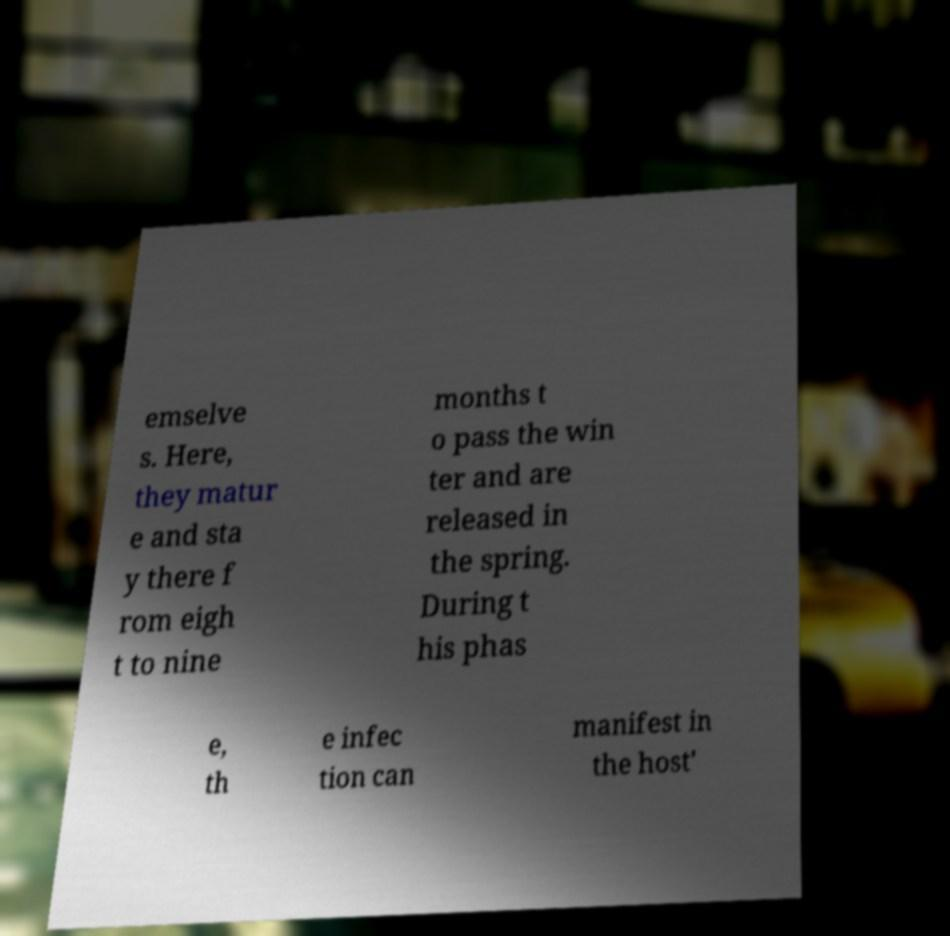Please read and relay the text visible in this image. What does it say? emselve s. Here, they matur e and sta y there f rom eigh t to nine months t o pass the win ter and are released in the spring. During t his phas e, th e infec tion can manifest in the host' 